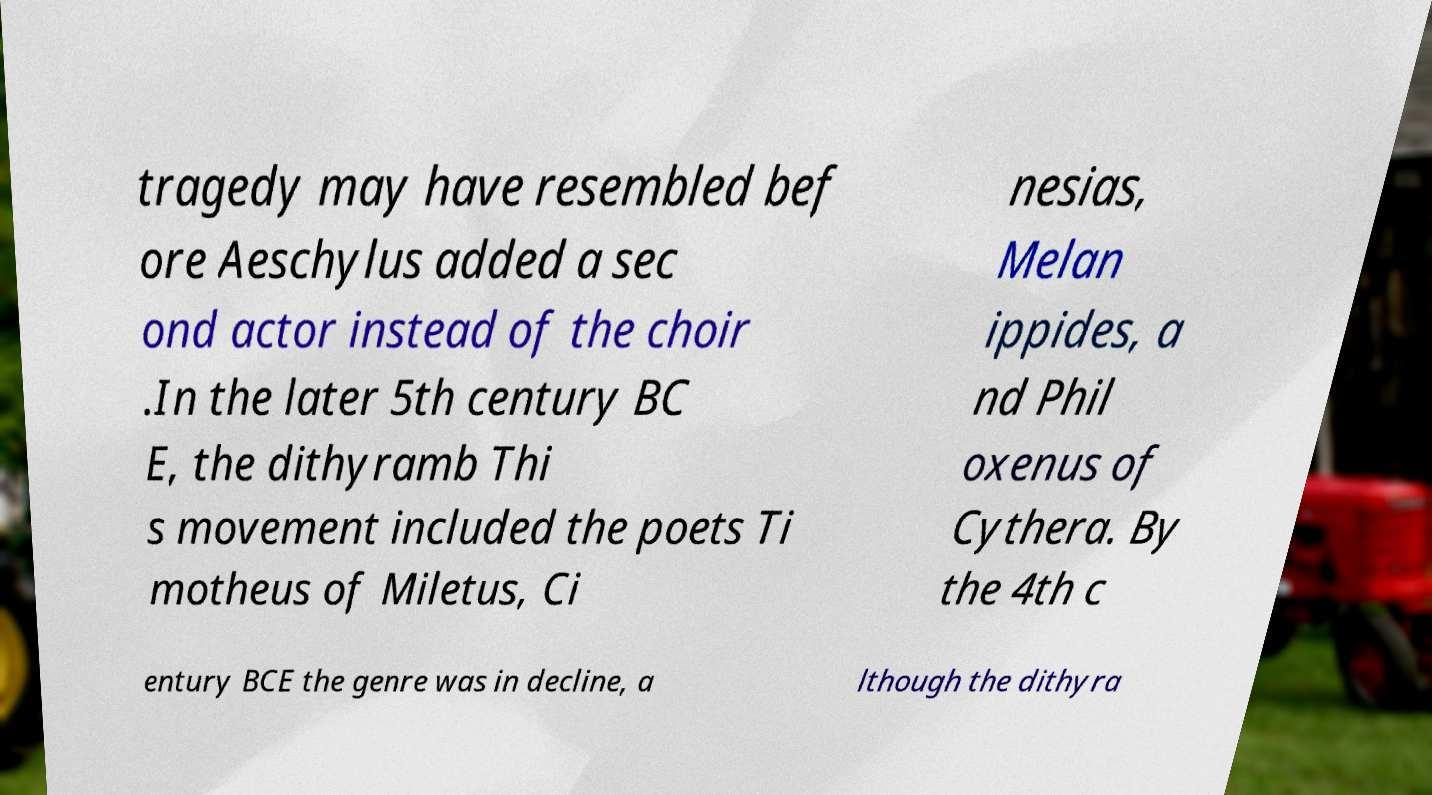Could you assist in decoding the text presented in this image and type it out clearly? tragedy may have resembled bef ore Aeschylus added a sec ond actor instead of the choir .In the later 5th century BC E, the dithyramb Thi s movement included the poets Ti motheus of Miletus, Ci nesias, Melan ippides, a nd Phil oxenus of Cythera. By the 4th c entury BCE the genre was in decline, a lthough the dithyra 